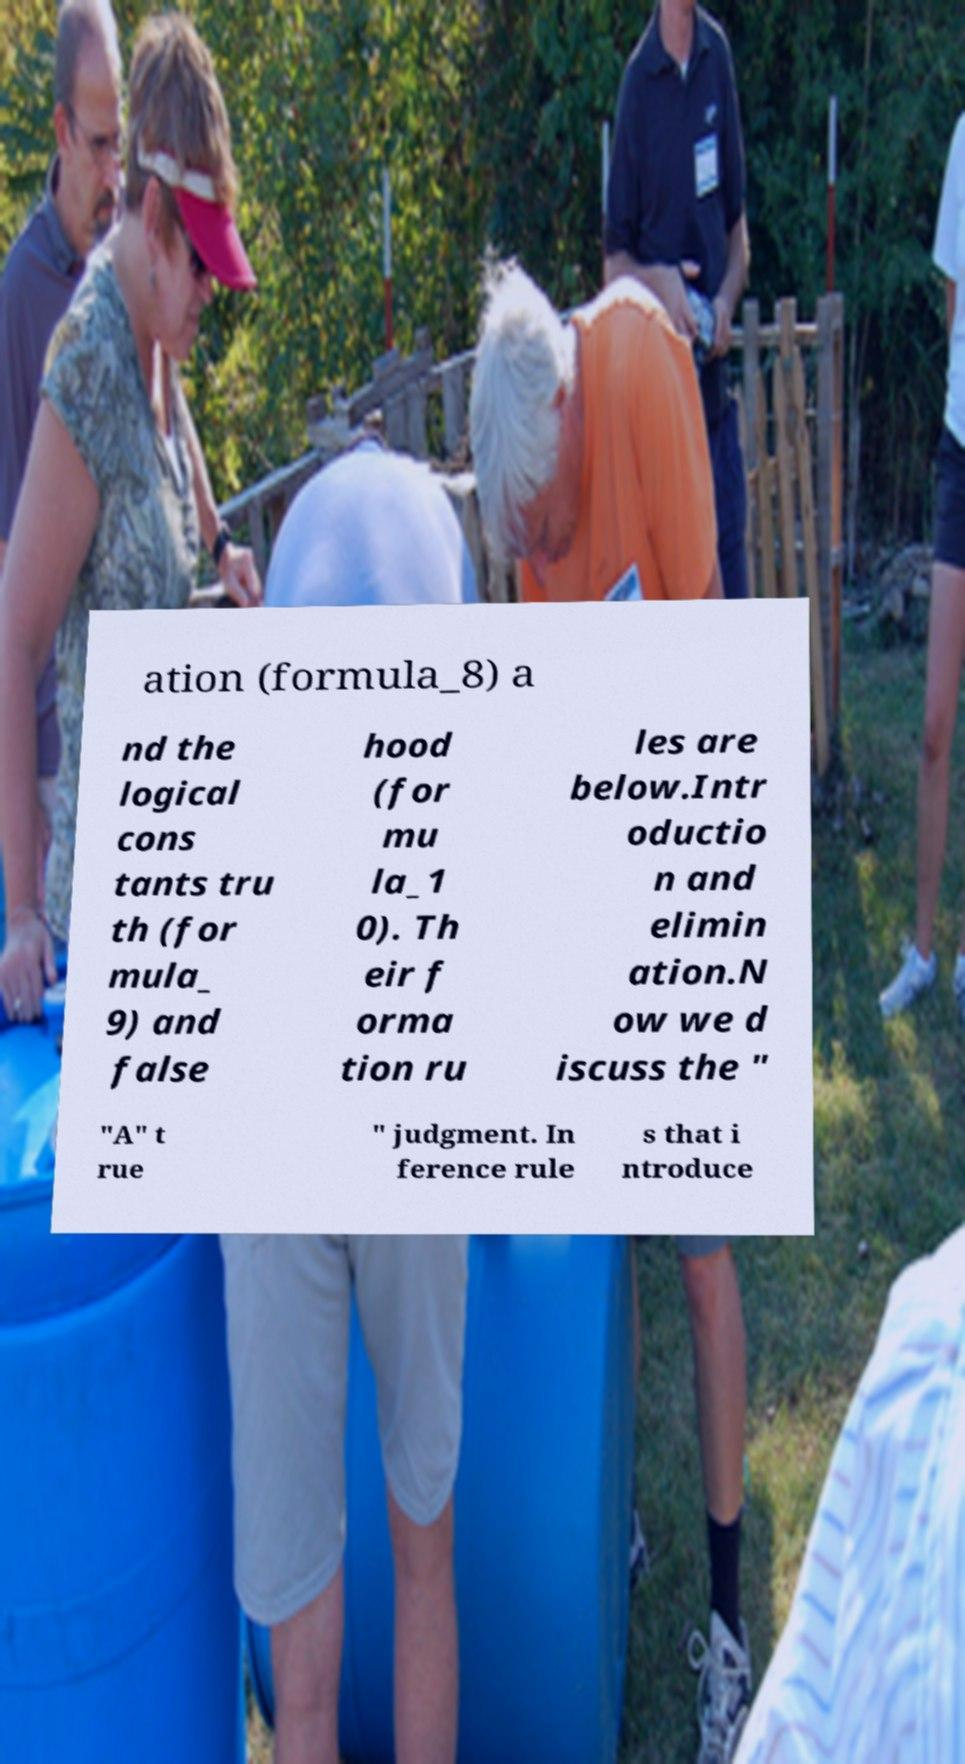Could you assist in decoding the text presented in this image and type it out clearly? ation (formula_8) a nd the logical cons tants tru th (for mula_ 9) and false hood (for mu la_1 0). Th eir f orma tion ru les are below.Intr oductio n and elimin ation.N ow we d iscuss the " "A" t rue " judgment. In ference rule s that i ntroduce 